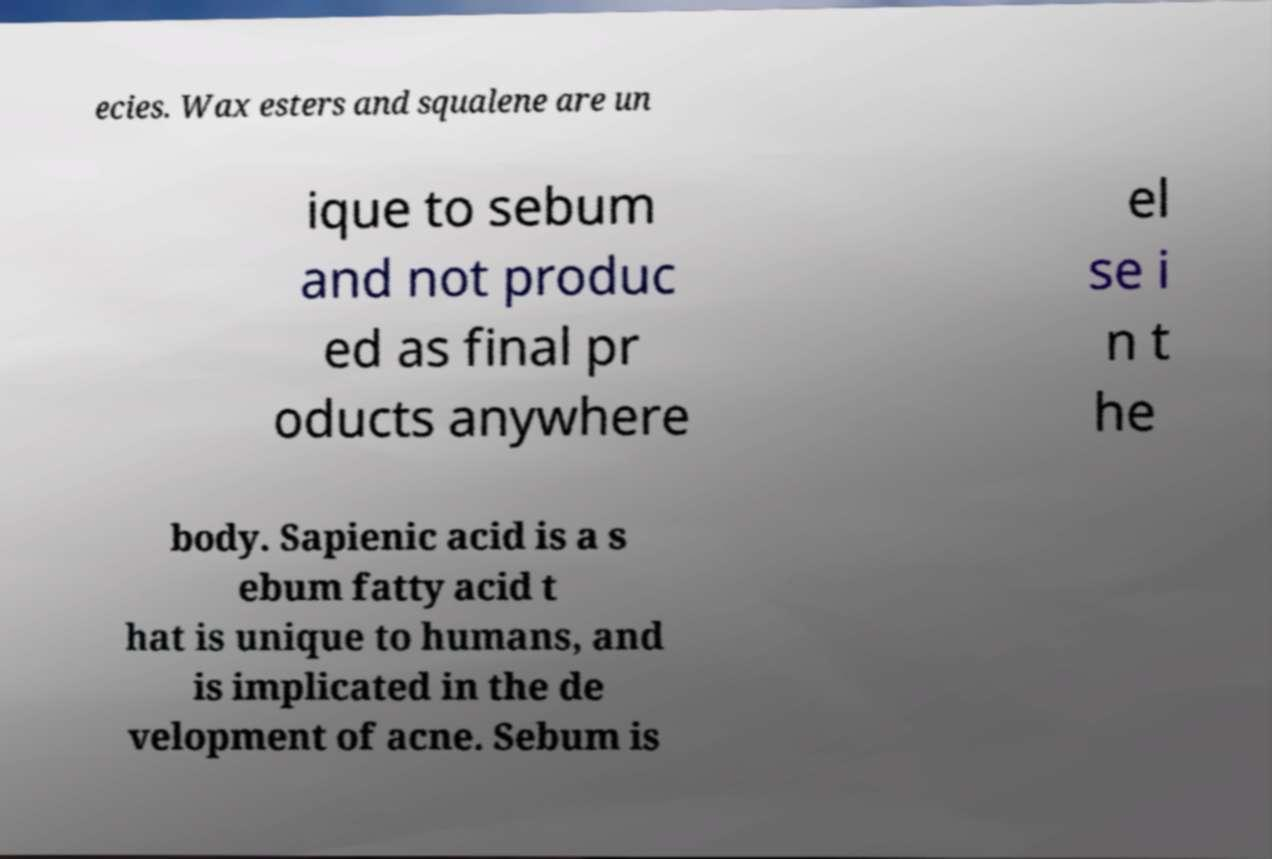Please read and relay the text visible in this image. What does it say? ecies. Wax esters and squalene are un ique to sebum and not produc ed as final pr oducts anywhere el se i n t he body. Sapienic acid is a s ebum fatty acid t hat is unique to humans, and is implicated in the de velopment of acne. Sebum is 